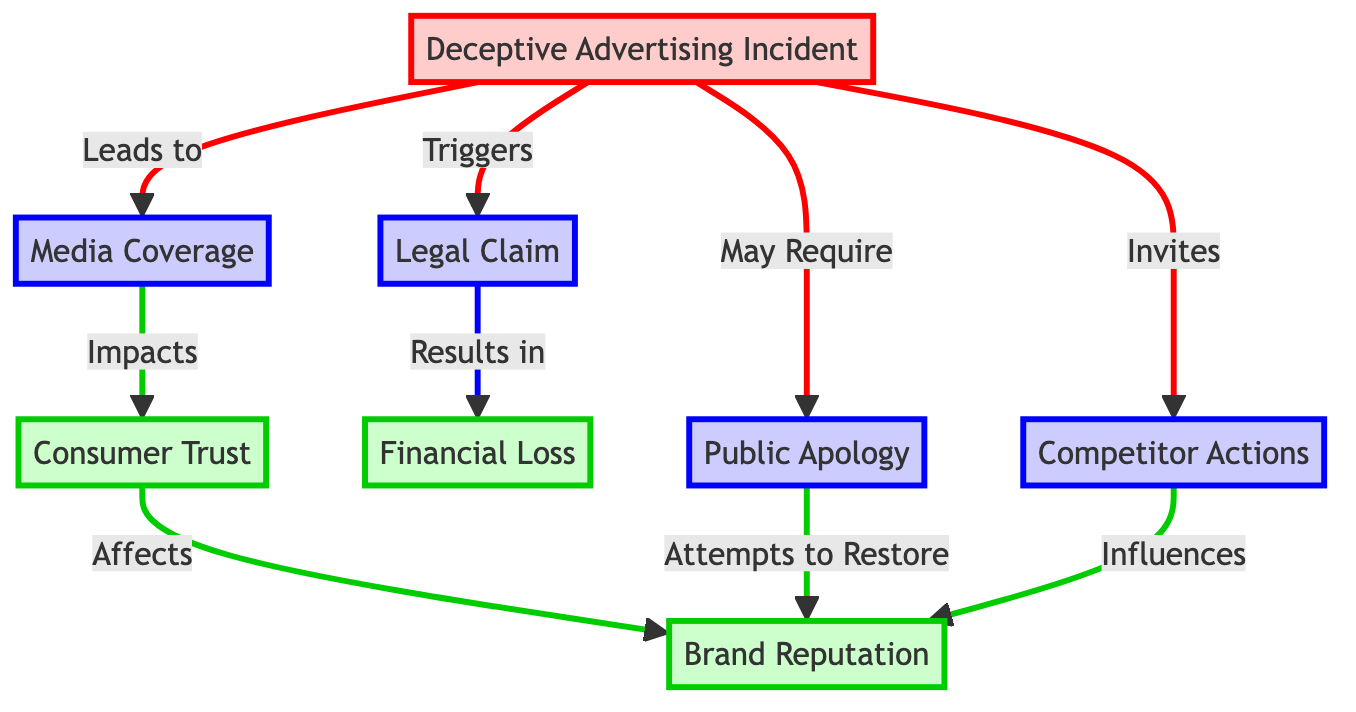What triggers a legal claim? The diagram clearly shows that the deceptive advertising incident triggers a legal claim as it is the starting point of the flow.
Answer: Deceptive Advertising Incident What impacts consumer trust? According to the diagram, media coverage stemming from the deceptive advertising incident impacts consumer trust.
Answer: Media Coverage How many impact nodes are in the diagram? The diagram contains four impact nodes that represent the impacts related to brand reputation: consumer trust, brand reputation itself, financial loss, and competitor actions.
Answer: Four What does a public apology attempt to restore? The diagram indicates that a public apology attempts to restore the brand reputation after a deceptive advertising incident.
Answer: Brand Reputation What influences brand reputation as per the diagram? The diagram shows that both competitor actions and consumer trust influence brand reputation, so it requires considering both connections for an accurate answer.
Answer: Consumer Trust and Competitor Actions What may a deceptive advertising incident require? The diagram indicates that a deceptive advertising incident may require a public apology, representing an action for addressing the issue.
Answer: Public Apology How does a legal claim relate to financial loss? The diagram illustrates a direct relationship where a legal claim results in financial loss, showing that one leads to the other.
Answer: Results in Financial Loss What action does media coverage invite? The diagram specifies that media coverage invites competitor actions, which demonstrates how media attention can affect the competitive landscape.
Answer: Competitor Actions What leads to a change in brand reputation following a deceptive advertising incident? The diagram shows that media coverage impacts consumer trust, which subsequently affects brand reputation, illustrating a flow of influence.
Answer: Media Coverage through Consumer Trust 